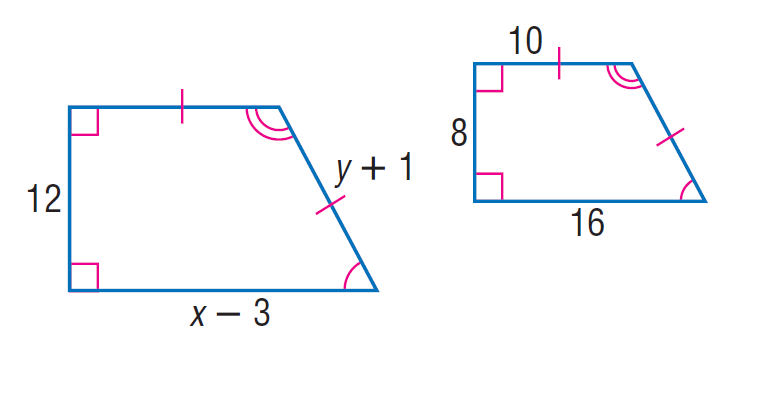Answer the mathemtical geometry problem and directly provide the correct option letter.
Question: Each pair of polygons is similar. Find x.
Choices: A: 8 B: 20 C: 27 D: 820 C 